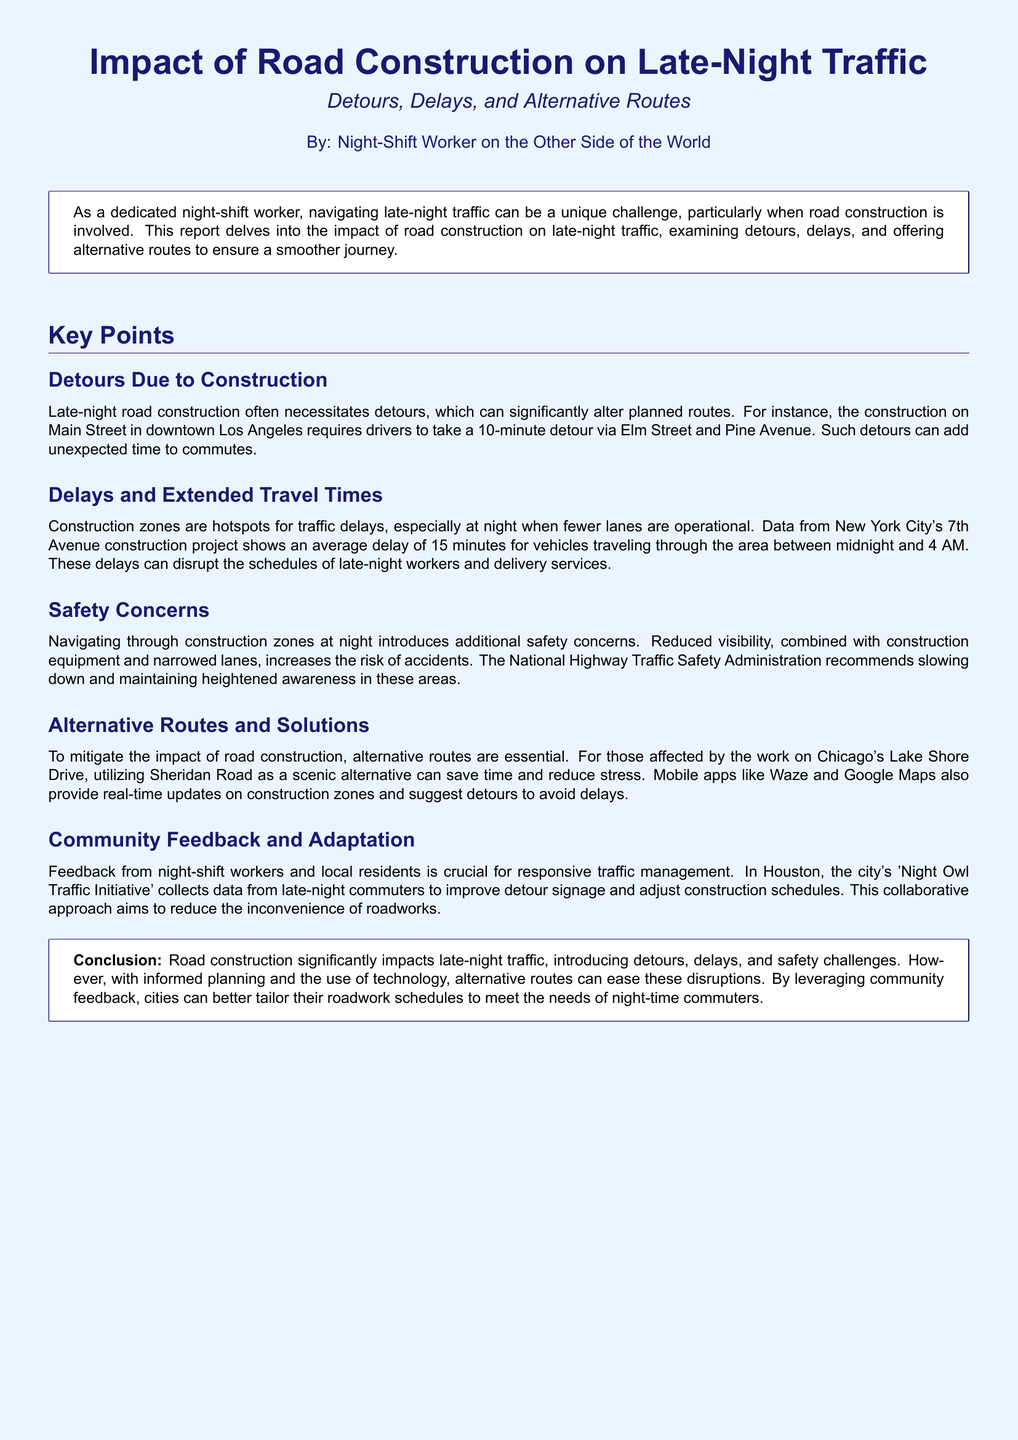What is the average delay during construction in New York City? The document states that the average delay for vehicles is 15 minutes during the construction period.
Answer: 15 minutes What is the name of the initiative in Houston? The 'Night Owl Traffic Initiative' is mentioned as the program collecting data from late-night commuters.
Answer: Night Owl Traffic Initiative Which street requires a 10-minute detour in downtown Los Angeles? The report highlights that Main Street requires drivers to take a detour via Elm Street and Pine Avenue.
Answer: Main Street What is an alternative route suggested for Chicago's Lake Shore Drive? The document suggests using Sheridan Road as a scenic alternative route.
Answer: Sheridan Road What time frame shows the average delay in New York City construction? The document specifies that the average delay occurs between midnight and 4 AM.
Answer: Midnight to 4 AM What safety concern is highlighted when navigating through construction zones at night? The report mentions increased risk of accidents due to reduced visibility and construction equipment.
Answer: Increased risk of accidents What technology is recommended for real-time updates on construction zones? The document suggests using mobile apps like Waze and Google Maps for updates.
Answer: Waze and Google Maps How does community feedback help in traffic management according to the document? The feedback is crucial for responsive traffic management and improving detour signage.
Answer: Improving detour signage 